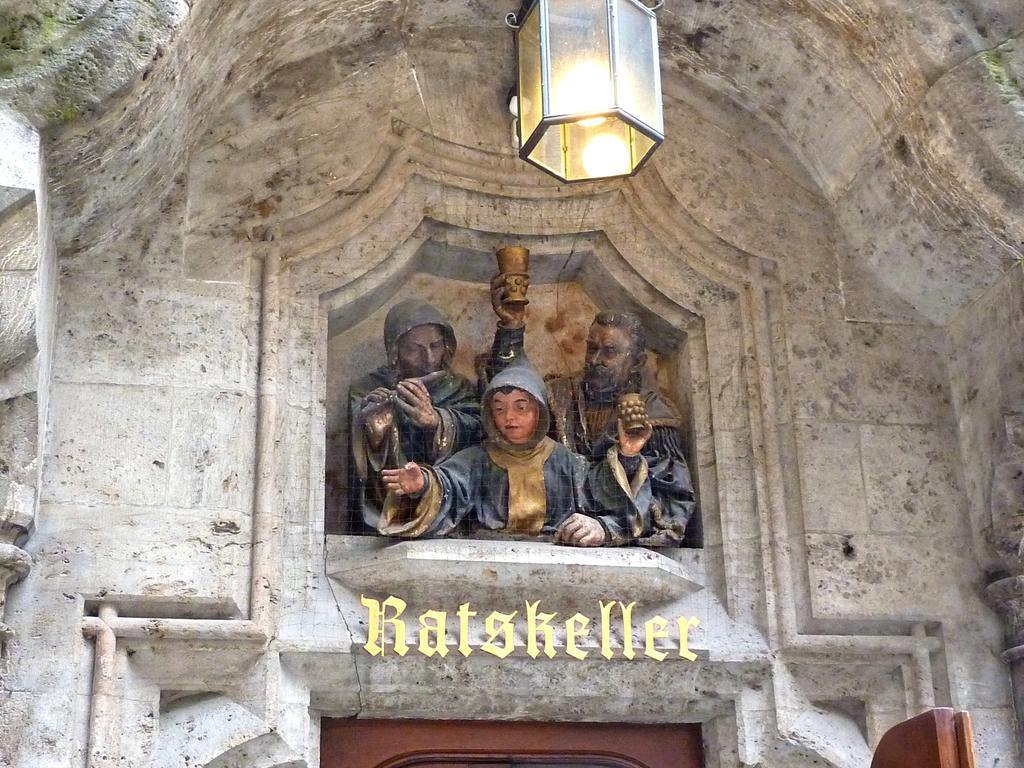In one or two sentences, can you explain what this image depicts? In this image I see the building and I see the sculptures over here and I see the light over here and I see something is written over here. 